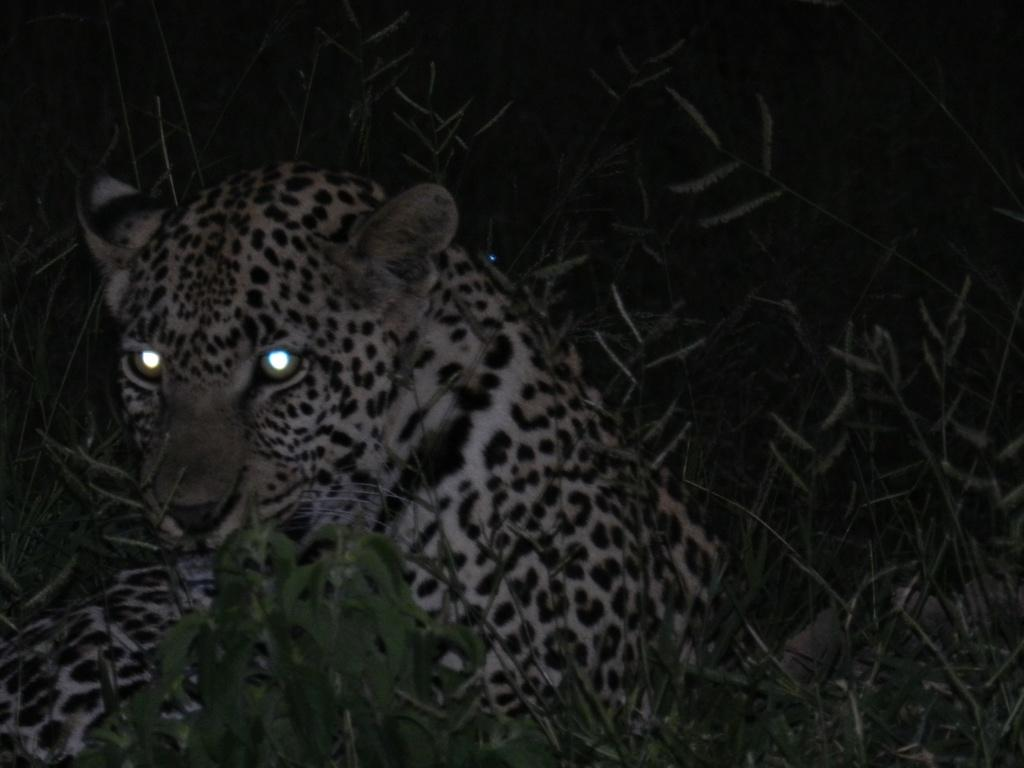What type of animal is in the image? There is a tiger in the image. What other elements can be seen in the image besides the tiger? There are plants and grass in the image. Where can the match be found in the image? There is no match present in the image. What type of street is visible in the image? There is no street visible in the image. 